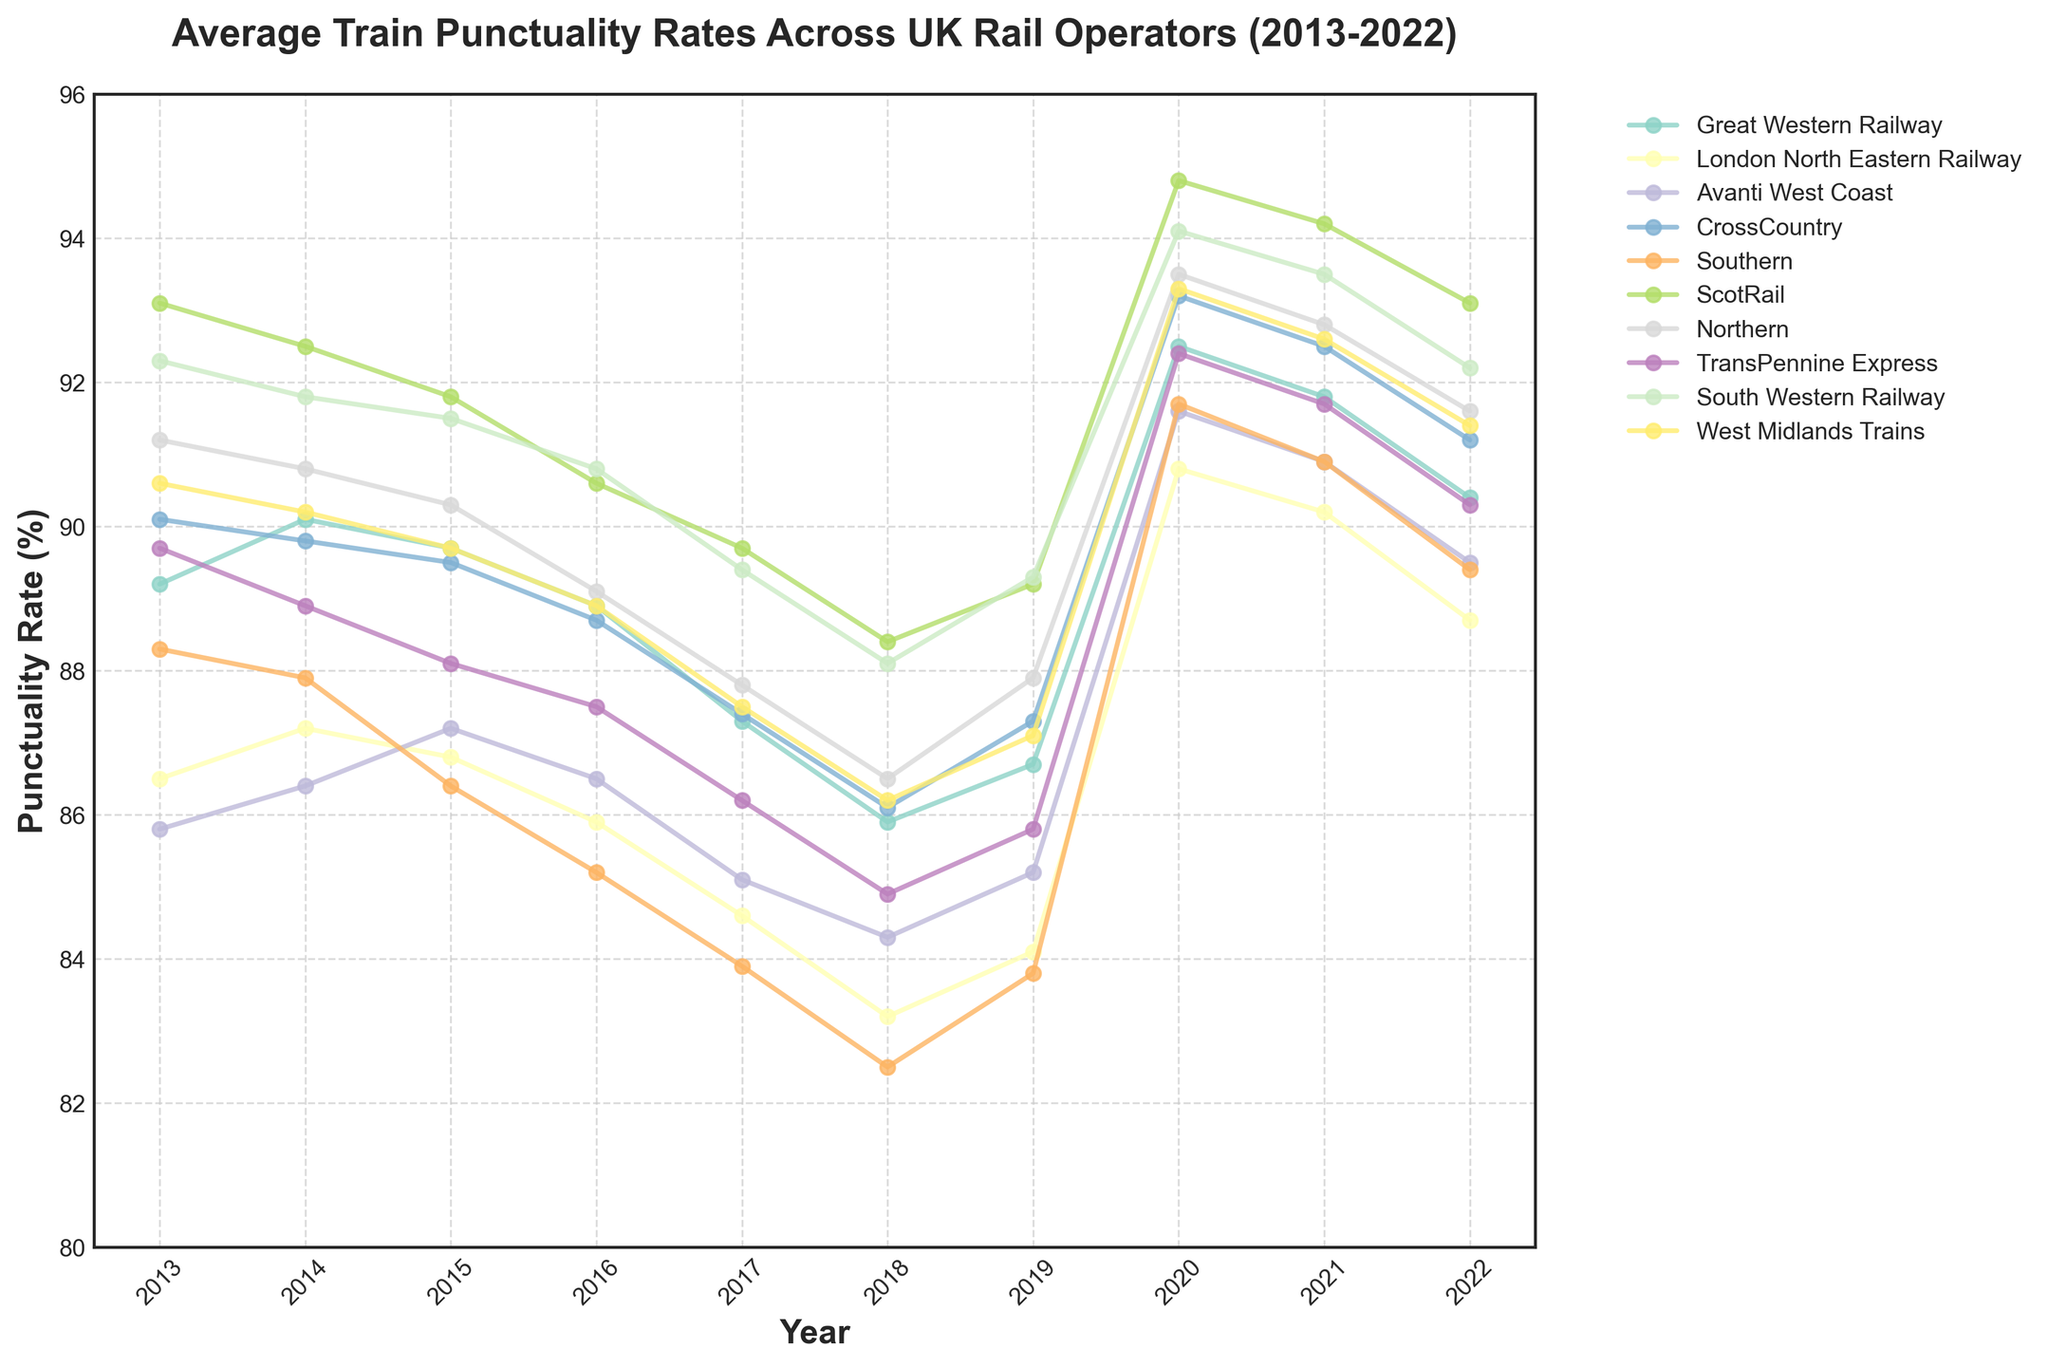Which rail operator had the highest punctuality rate in 2020? To find the answer, look at the data points for 2020 and identify the highest value. The highest punctuality rate in 2020 belongs to the operator with the top data point.
Answer: ScotRail How did TransPennine Express's punctuality rate change from 2017 to 2022? Examine the data points for TransPennine Express for the years 2017 and 2022. Subtract the 2017 value from the 2022 value to find the change.
Answer: +4.1% What is the average punctuality rate for West Midlands Trains over the decade? Sum the punctuality rates for West Midlands Trains from 2013 to 2022 and divide by 10 (the number of years). Calculation: (90.6 + 90.2 + 89.7 + 88.9 + 87.5 + 86.2 + 87.1 + 93.3 + 92.6 + 91.4) / 10 = 89.75
Answer: 89.75% Which rail operator had a consistent increase in punctuality rate from 2017 to 2020? Examine the punctuality rates for all operators between 2017 and 2020. Look for an operator where the punctuality rate increases every consecutive year.
Answer: Great Western Railway Who had a greater improvement in punctuality rates from 2019 to 2020: Avanti West Coast or Northern? Calculate the difference in punctuality rates from 2019 to 2020 for both operators and compare the two values. For Avanti West Coast: 91.6 - 85.2 = 6.4, for Northern: 93.5 - 87.9 = 5.6. Compare these differences.
Answer: Avanti West Coast Which operator had the largest drop in punctuality rate between any two consecutive years? Identify the year-over-year changes for each operator and find the largest single drop in value.
Answer: Southern (2014-2015, drop of 1.5%) What is the overall trend in punctuality rates for London North Eastern Railway over the decade? Look at the data points for London North Eastern Railway from 2013 to 2022. Identify the general direction of the trend over the decade.
Answer: Decreasing Compare the punctuality rates of Southern and CrossCountry in 2018. Which had a higher rate and by how much? Refer to the data points for Southern and CrossCountry in 2018. Subtract the punctuality rate of Southern from CrossCountry's rate.
Answer: CrossCountry by 3.6% Among the operators shown, who had the lowest punctuality rate in 2016? Identify the data point for each operator in 2016 and find the lowest value.
Answer: Southern By what percentage did punctuality for South Western Railway change from 2015 to 2016? Calculate the difference between 2015 and 2016 punctuality rates for South Western Railway, then divide by the 2015 value and multiply by 100 to get the percentage change. Calculation: ((90.8 - 91.5) / 91.5) * 100 = -0.76
Answer: -0.76% 